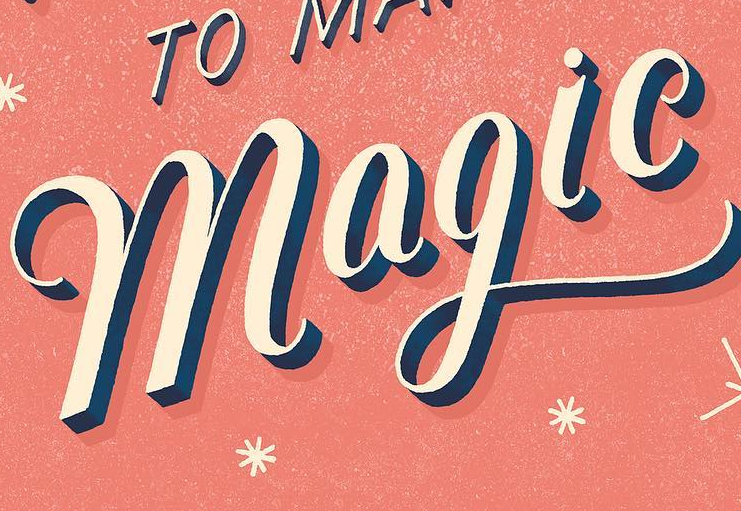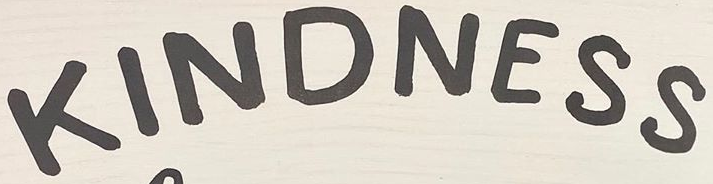What text appears in these images from left to right, separated by a semicolon? magic; KINDNESS 